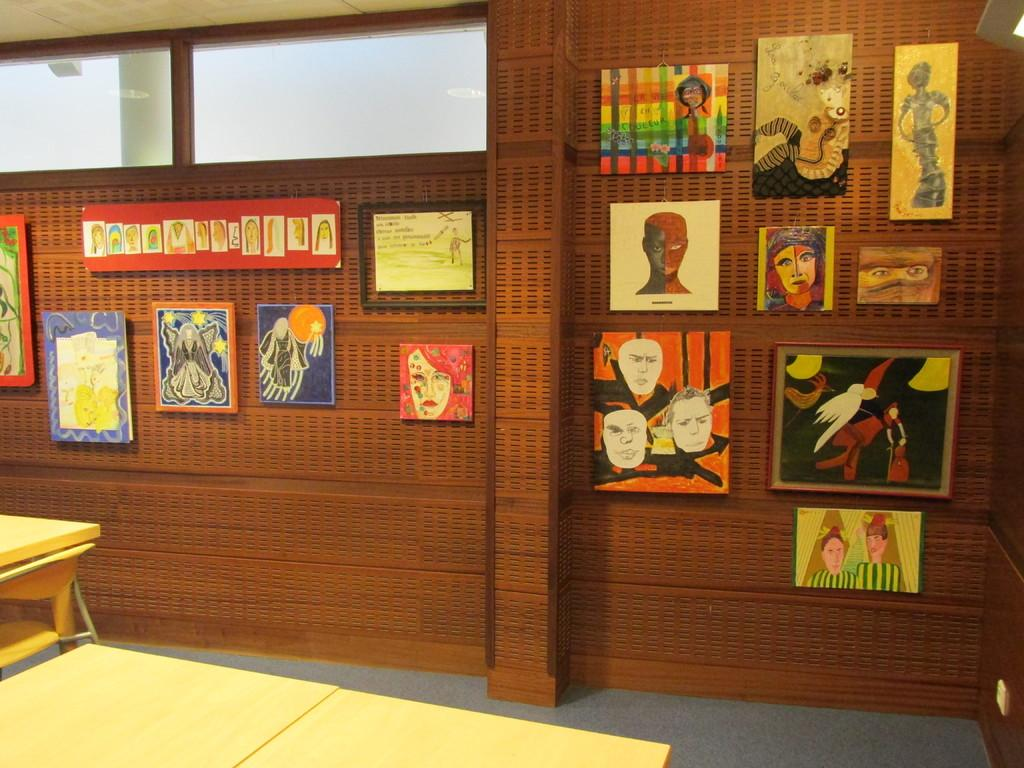What type of furniture can be seen in the image? There are tables in the image. What material is visible in the image? Glass is visible in the image. What part of the room is visible in the image? The floor is visible in the image. What decorative elements are present on the wall in the image? There are frames on the wall in the image. What type of breakfast is being served on the tables in the image? There is no breakfast visible in the image; only tables, glass, the floor, and frames on the wall are present. What type of scale is used to weigh the frames on the wall in the image? There is no scale present in the image; only frames on the wall are visible. 